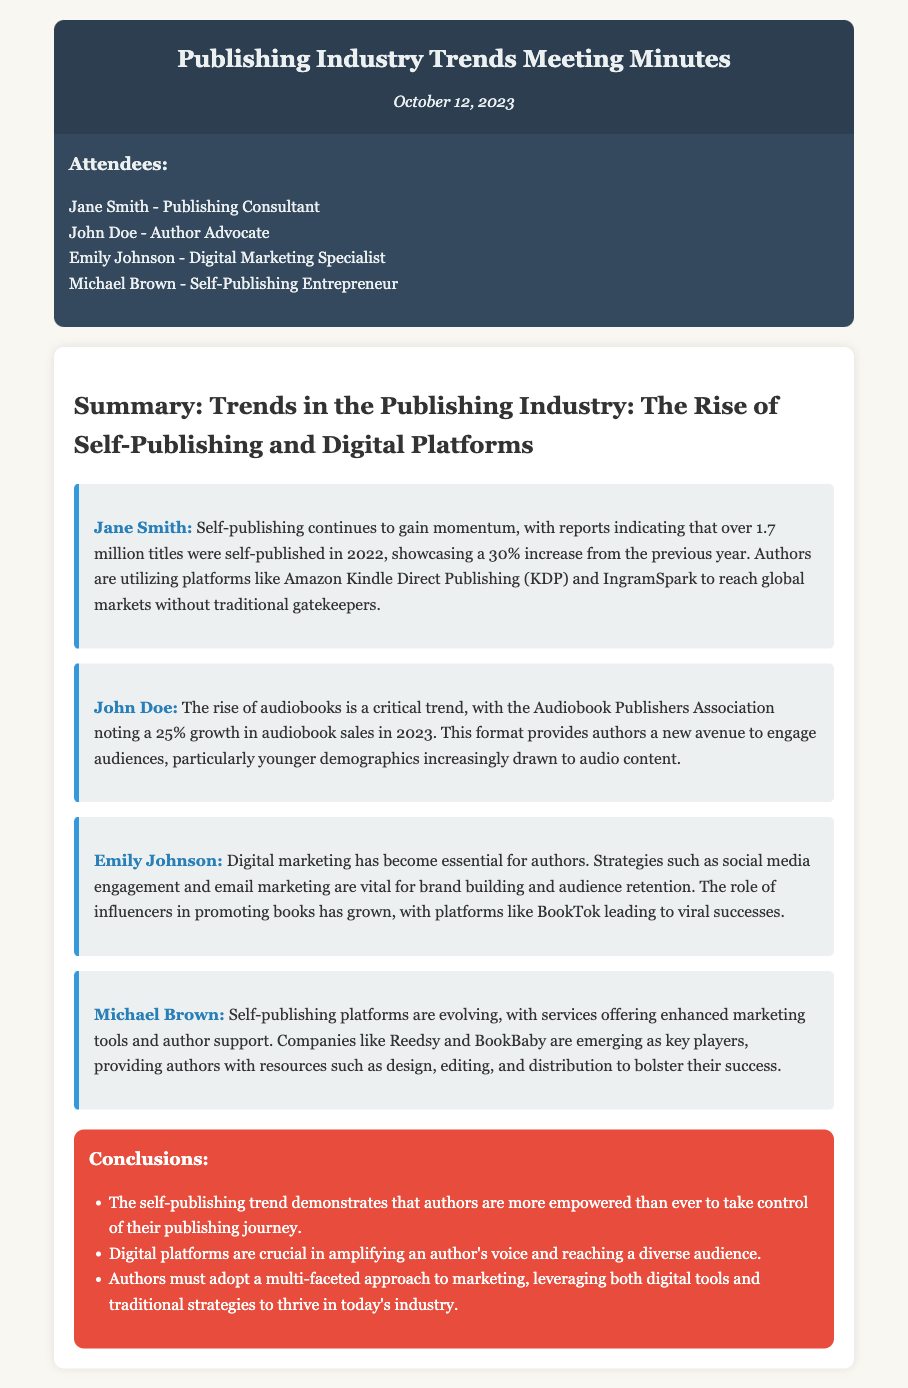What is the date of the meeting? The date of the meeting is clearly stated at the top of the document.
Answer: October 12, 2023 Who confirmed the growth in self-publishing titles? Jane Smith is the one who provided the statistic about the growth in self-publishing titles in her insight.
Answer: Jane Smith How much did self-published titles increase in 2022? The document mentions a specific percentage increase in self-published titles for 2022.
Answer: 30% Which platform is primarily mentioned for self-publishing? The document lists a specific platform that is popular among self-publishing authors in Jane Smith's insight.
Answer: Amazon Kindle Direct Publishing What percentage growth did audiobook sales see in 2023? The information is provided in John Doe's insight regarding audiobook sales growth.
Answer: 25% What type of marketing strategies are essential for authors according to Emily Johnson? Emily Johnson discusses the type of marketing that authors should focus on in her insight.
Answer: Digital marketing Which platforms are mentioned as emerging players in self-publishing support? Michael Brown lists companies that are providing enhanced support for self-publishing authors.
Answer: Reedsy and BookBaby What key point underscores the self-publishing trend in the conclusions? The conclusions section highlights a specific aspect of self-publishing empowerment for authors.
Answer: Empowered What is emphasized as crucial for authors to amplify their voice? The conclusions mention a specific aspect that is vital for authors in reaching their audience.
Answer: Digital platforms 